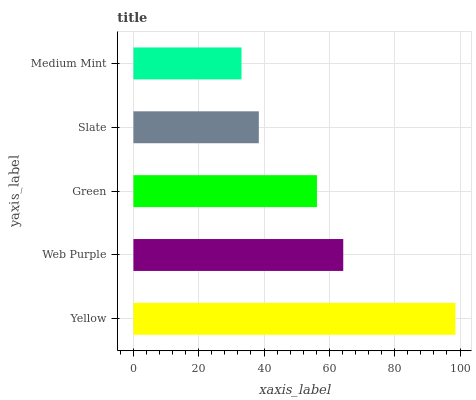Is Medium Mint the minimum?
Answer yes or no. Yes. Is Yellow the maximum?
Answer yes or no. Yes. Is Web Purple the minimum?
Answer yes or no. No. Is Web Purple the maximum?
Answer yes or no. No. Is Yellow greater than Web Purple?
Answer yes or no. Yes. Is Web Purple less than Yellow?
Answer yes or no. Yes. Is Web Purple greater than Yellow?
Answer yes or no. No. Is Yellow less than Web Purple?
Answer yes or no. No. Is Green the high median?
Answer yes or no. Yes. Is Green the low median?
Answer yes or no. Yes. Is Yellow the high median?
Answer yes or no. No. Is Web Purple the low median?
Answer yes or no. No. 